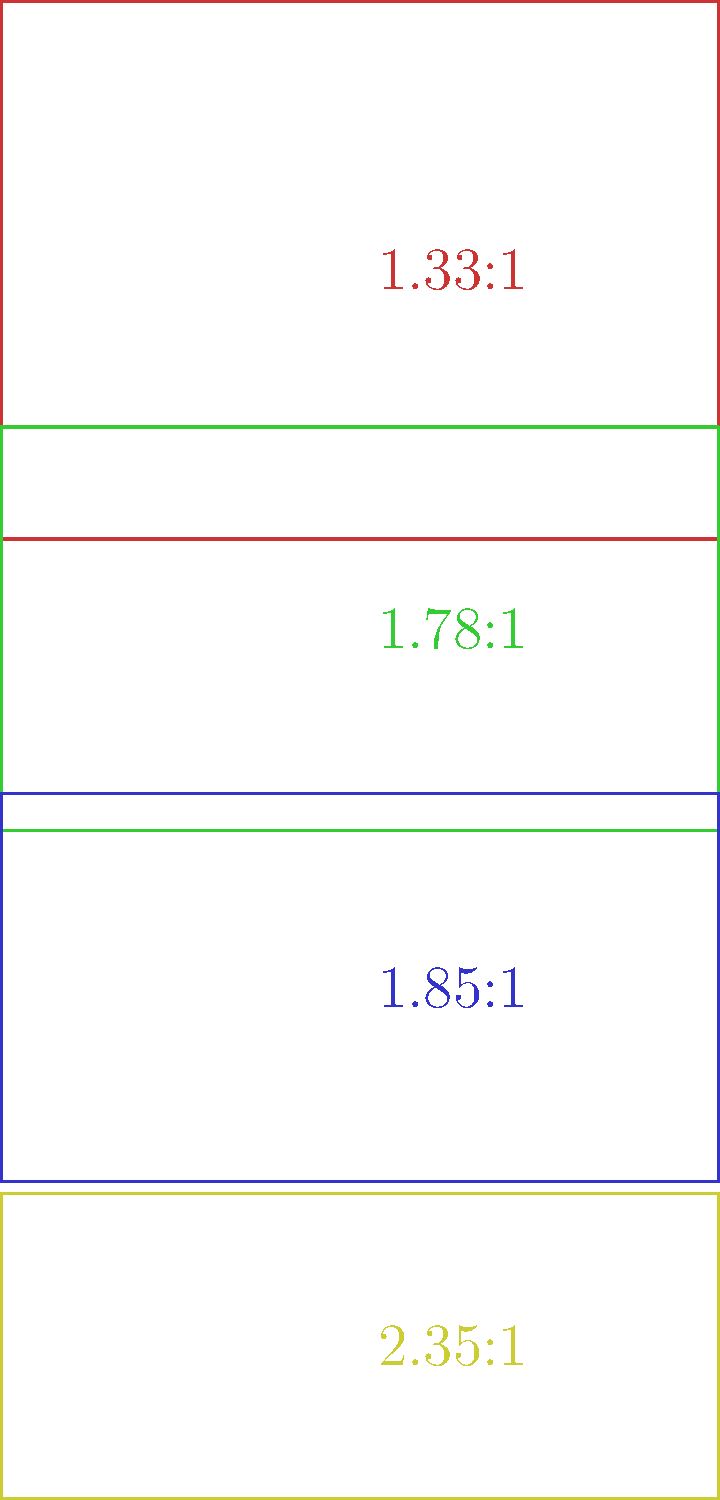As an experimental filmmaker exploring collage techniques, you're considering various aspect ratios for your next project. The image shows four common aspect ratios used in filmmaking. Which of these ratios would be most suitable for creating a film that combines vintage television footage with modern widescreen cinematography, and why? To answer this question, let's analyze each aspect ratio and its implications for experimental filmmaking:

1. 1.33:1 (4:3): This is the classic television aspect ratio, used for most broadcast TV and early films. It's nearly square and was the standard for home viewing until the late 1990s.

2. 1.78:1 (16:9): This is the current standard for HDTV and many digital video formats. It's wider than 4:3 but not as wide as some cinematic formats.

3. 1.85:1: A common theatrical widescreen format, slightly wider than 16:9. It's been used in cinema since the 1950s and is still popular today.

4. 2.35:1: The widest format shown, often used for epic or panoramic films. It provides a very cinematic look but can be challenging to view on standard displays.

For a project combining vintage TV footage with modern widescreen cinematography, the most suitable ratio would be 16:9 (1.78:1). Here's why:

1. Versatility: 16:9 is a good compromise between the older 4:3 format and wider cinematic ratios.
2. Compatibility: It's the current standard for most digital platforms and TVs, ensuring wider accessibility.
3. Artistic potential: The 16:9 ratio allows for creative composition when combining 4:3 vintage footage (which can be pillarboxed) with modern widescreen material.
4. Collage possibilities: This ratio provides enough width for interesting juxtapositions of vintage and modern footage side-by-side if desired.

Using 16:9 would allow you to incorporate 4:3 footage without excessive letterboxing, while still maintaining a contemporary widescreen aesthetic. This balance makes it ideal for an experimental collage that bridges different eras of filmmaking.
Answer: 16:9 (1.78:1) 